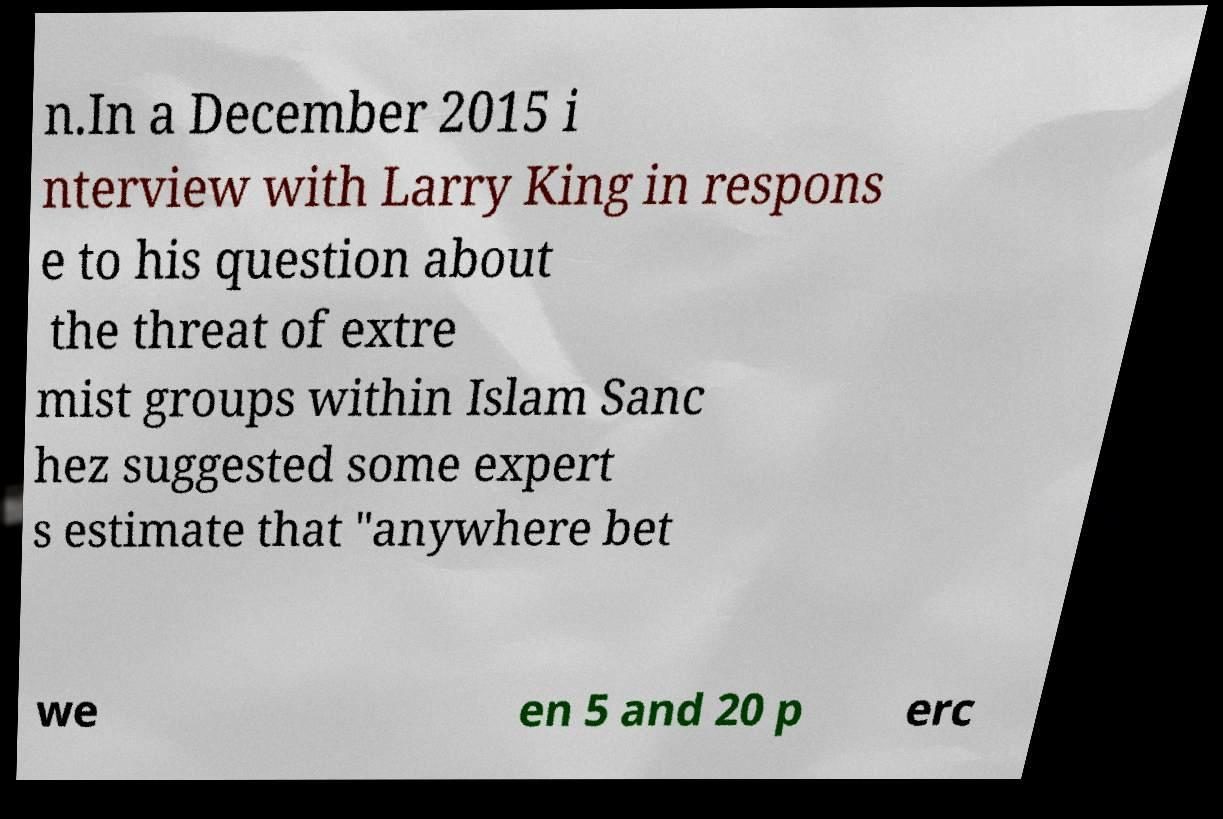There's text embedded in this image that I need extracted. Can you transcribe it verbatim? n.In a December 2015 i nterview with Larry King in respons e to his question about the threat of extre mist groups within Islam Sanc hez suggested some expert s estimate that "anywhere bet we en 5 and 20 p erc 